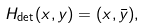Convert formula to latex. <formula><loc_0><loc_0><loc_500><loc_500>H _ { \det } ( x , y ) = ( x , \bar { y } ) ,</formula> 